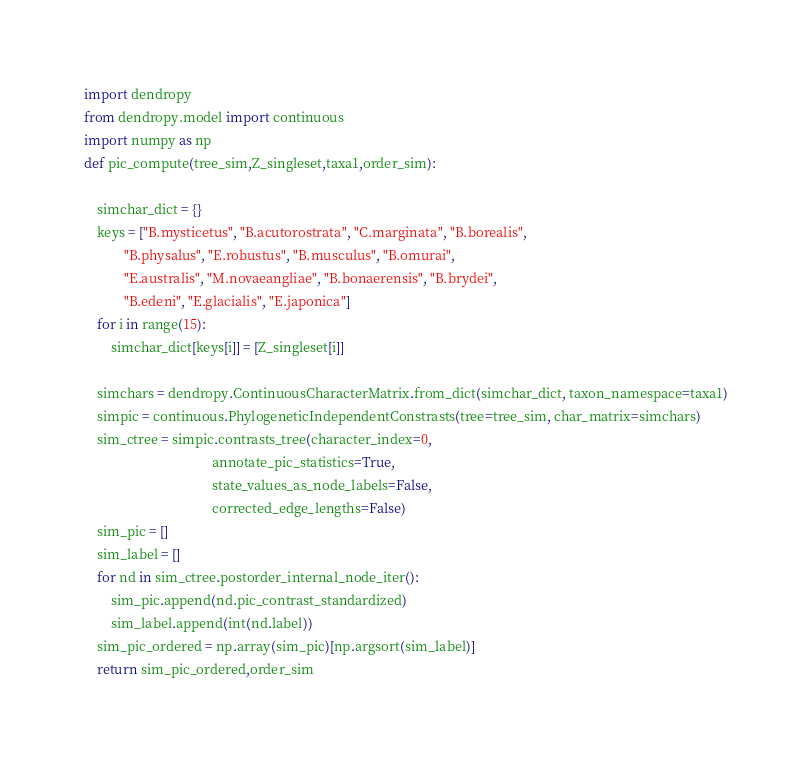<code> <loc_0><loc_0><loc_500><loc_500><_Python_>import dendropy
from dendropy.model import continuous
import numpy as np
def pic_compute(tree_sim,Z_singleset,taxa1,order_sim):

    simchar_dict = {}
    keys = ["B.mysticetus", "B.acutorostrata", "C.marginata", "B.borealis",
            "B.physalus", "E.robustus", "B.musculus", "B.omurai",
            "E.australis", "M.novaeangliae", "B.bonaerensis", "B.brydei",
            "B.edeni", "E.glacialis", "E.japonica"]
    for i in range(15):
        simchar_dict[keys[i]] = [Z_singleset[i]]

    simchars = dendropy.ContinuousCharacterMatrix.from_dict(simchar_dict, taxon_namespace=taxa1)
    simpic = continuous.PhylogeneticIndependentConstrasts(tree=tree_sim, char_matrix=simchars)
    sim_ctree = simpic.contrasts_tree(character_index=0,
                                      annotate_pic_statistics=True,
                                      state_values_as_node_labels=False,
                                      corrected_edge_lengths=False)
    sim_pic = []
    sim_label = []
    for nd in sim_ctree.postorder_internal_node_iter():
        sim_pic.append(nd.pic_contrast_standardized)
        sim_label.append(int(nd.label))
    sim_pic_ordered = np.array(sim_pic)[np.argsort(sim_label)]
    return sim_pic_ordered,order_sim</code> 